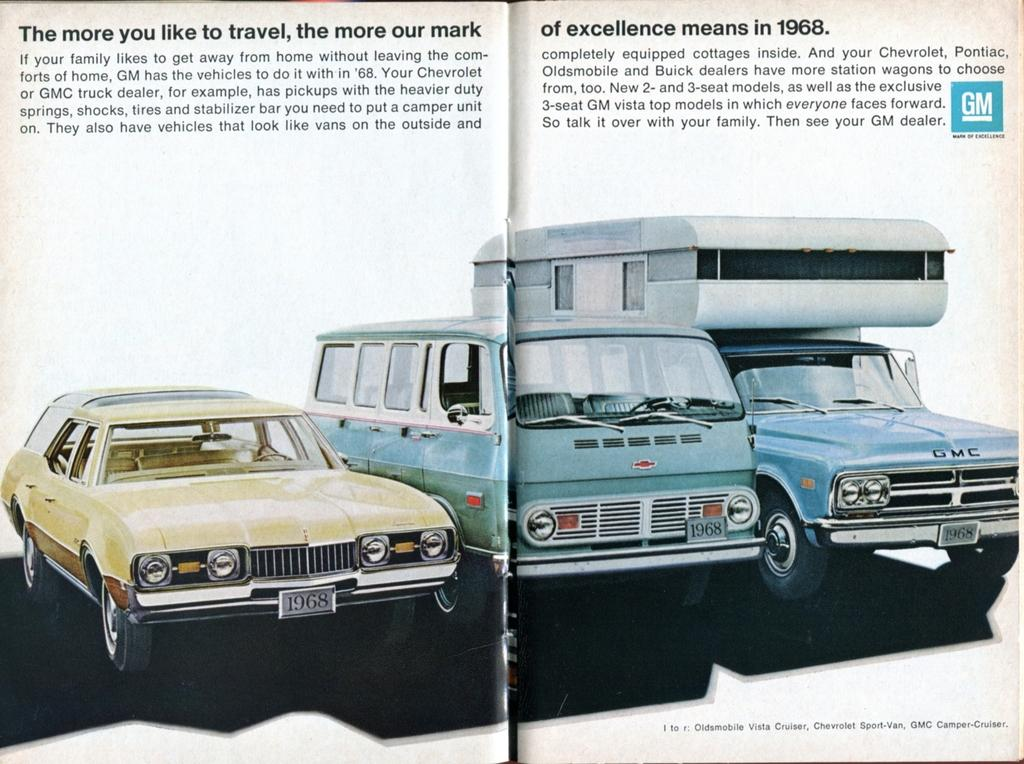<image>
Provide a brief description of the given image. An old ad displays GM cars from 1968, including a station wagon. 